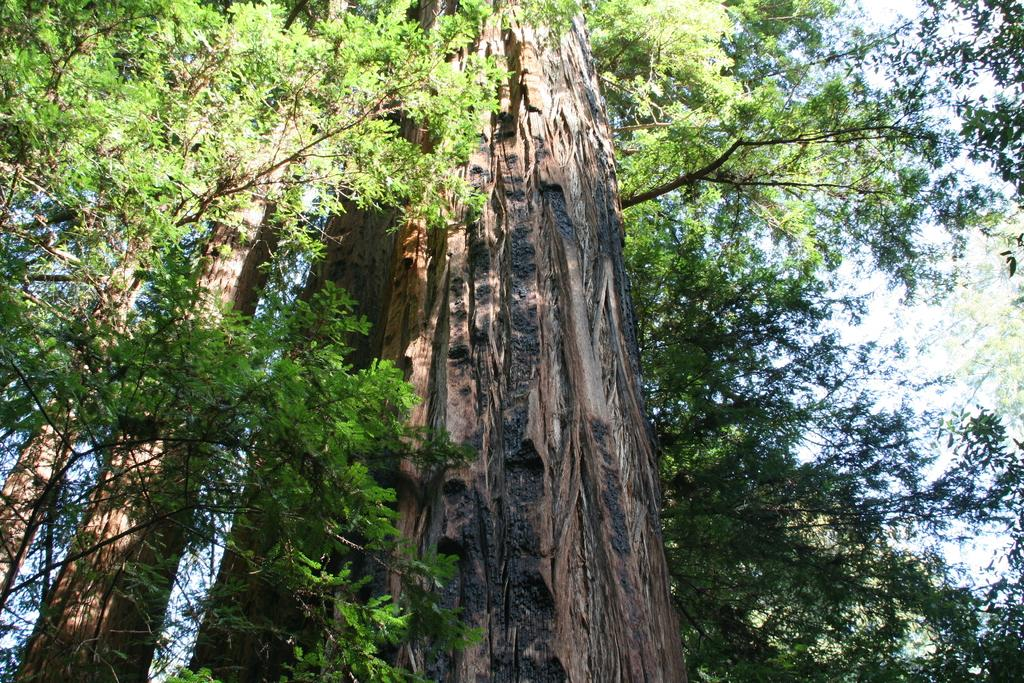What type of natural environment is depicted in the image? The image features many trees, indicating a forest or wooded area. What can be seen in the sky in the image? The sky is visible in the image, but no specific details about the sky are provided. Where is the chicken located in the image? There is no chicken present in the image. What type of map is shown in the image? There is no map present in the image. 